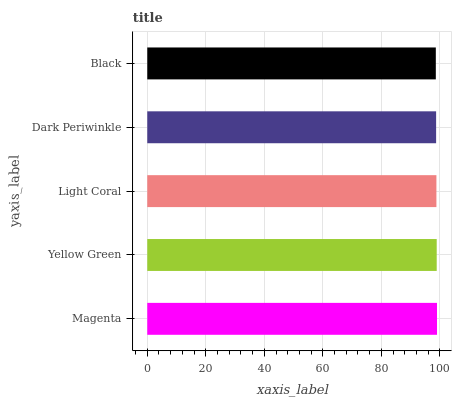Is Black the minimum?
Answer yes or no. Yes. Is Magenta the maximum?
Answer yes or no. Yes. Is Yellow Green the minimum?
Answer yes or no. No. Is Yellow Green the maximum?
Answer yes or no. No. Is Magenta greater than Yellow Green?
Answer yes or no. Yes. Is Yellow Green less than Magenta?
Answer yes or no. Yes. Is Yellow Green greater than Magenta?
Answer yes or no. No. Is Magenta less than Yellow Green?
Answer yes or no. No. Is Light Coral the high median?
Answer yes or no. Yes. Is Light Coral the low median?
Answer yes or no. Yes. Is Magenta the high median?
Answer yes or no. No. Is Magenta the low median?
Answer yes or no. No. 